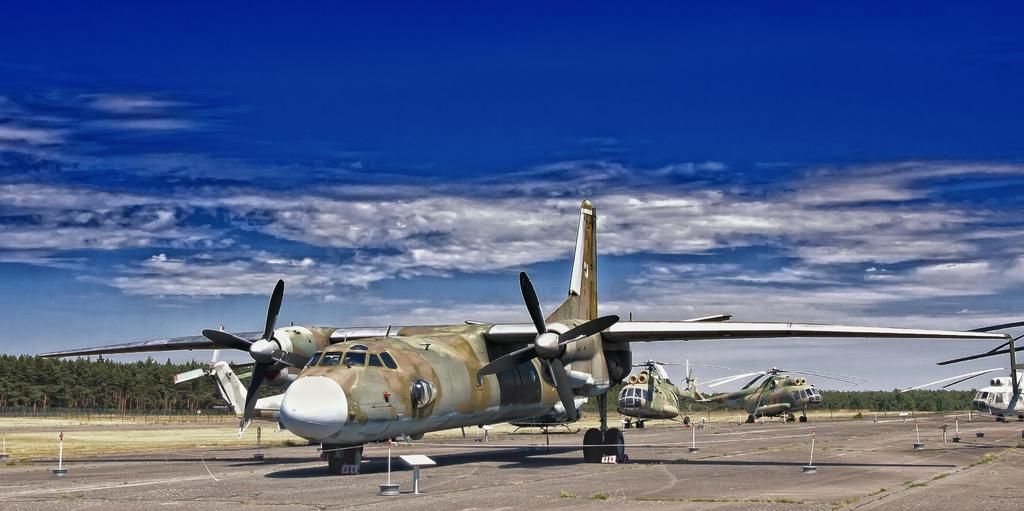What type of vehicles are present in the image? There is an airplane and helicopters in the image. Where are the airplane and helicopters located? They are on a runway in the image. What type of terrain is visible in the image? There is land visible in the image, and many trees can be seen. What is visible in the background of the image? The sky is visible in the background of the image, with clouds present. What type of mice can be seen playing brass instruments in the image? There are no mice or brass instruments present in the image. How does the care for the airplane and helicopters appear in the image? There is no indication of care for the airplane and helicopters in the image; it only shows them on a runway. 